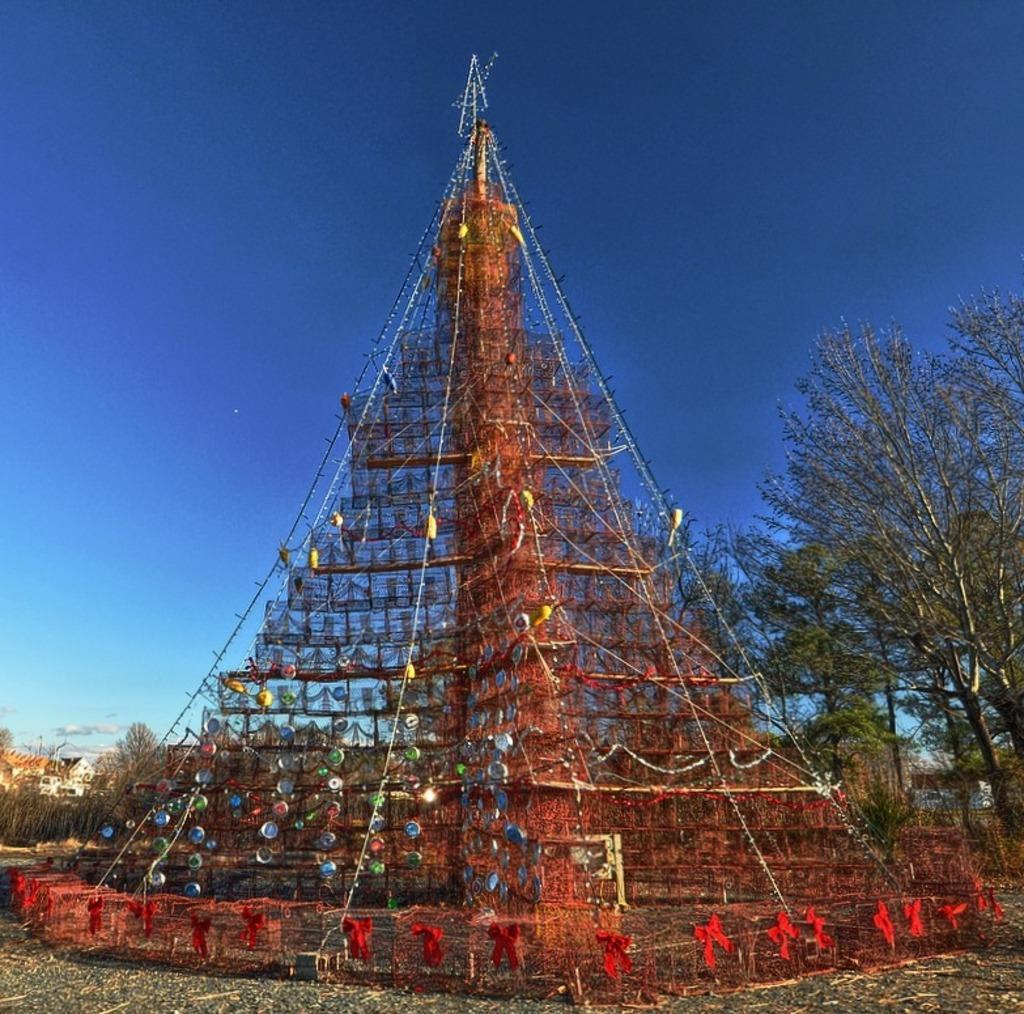In one or two sentences, can you explain what this image depicts? Here in this picture, in the middle we can see a tree decorated with lights and other gift items all around it and at the top we can see a star present and on the ground we can see plants and trees present and in the far we can see houses present and we can see the sky is clear. 